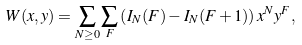<formula> <loc_0><loc_0><loc_500><loc_500>W ( x , y ) = \sum _ { N \geq 0 } \sum _ { F } \left ( I _ { N } ( F ) - I _ { N } ( F + 1 ) \right ) x ^ { N } y ^ { F } ,</formula> 